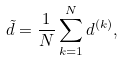<formula> <loc_0><loc_0><loc_500><loc_500>\tilde { d } = \frac { 1 } { N } \sum _ { k = 1 } ^ { N } d ^ { ( k ) } ,</formula> 